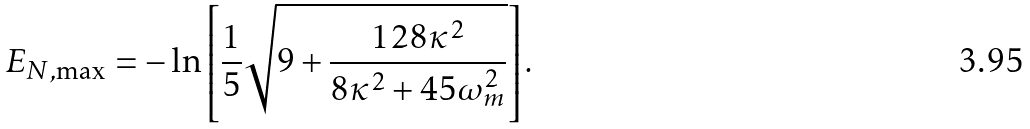Convert formula to latex. <formula><loc_0><loc_0><loc_500><loc_500>E _ { N , \max } = - \ln \left [ \frac { 1 } { 5 } \sqrt { 9 + \frac { 1 2 8 \kappa ^ { 2 } } { 8 \kappa ^ { 2 } + 4 5 \omega _ { m } ^ { 2 } } } \right ] .</formula> 